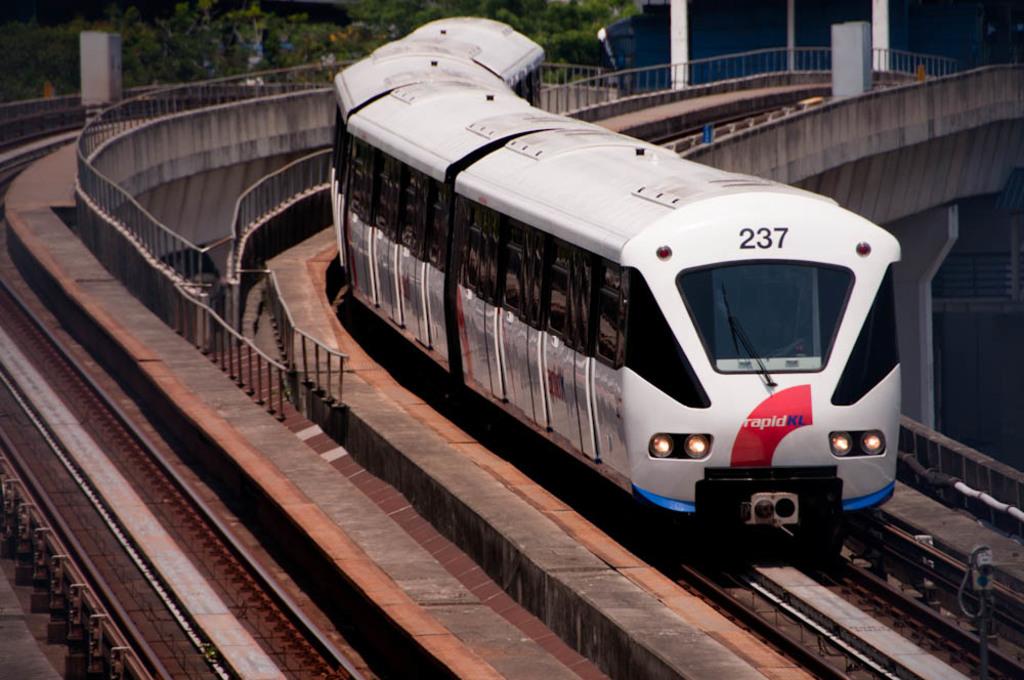What number is the train?
Give a very brief answer. 237. 